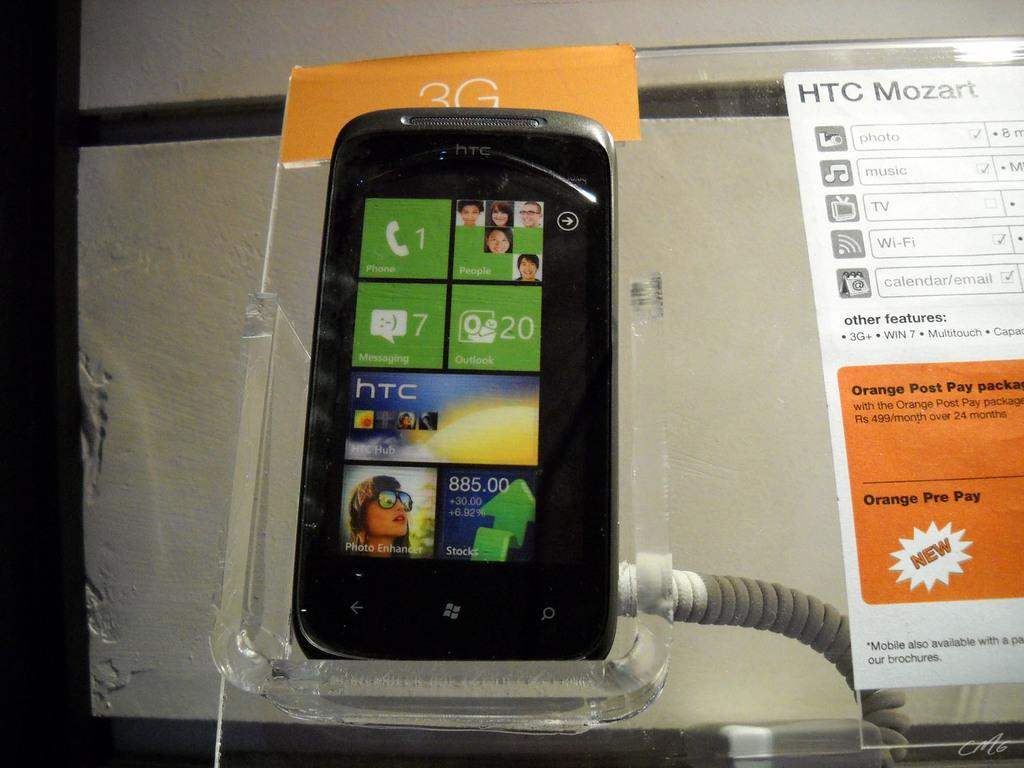<image>
Present a compact description of the photo's key features. A black HTC phone is showing its user interface. 